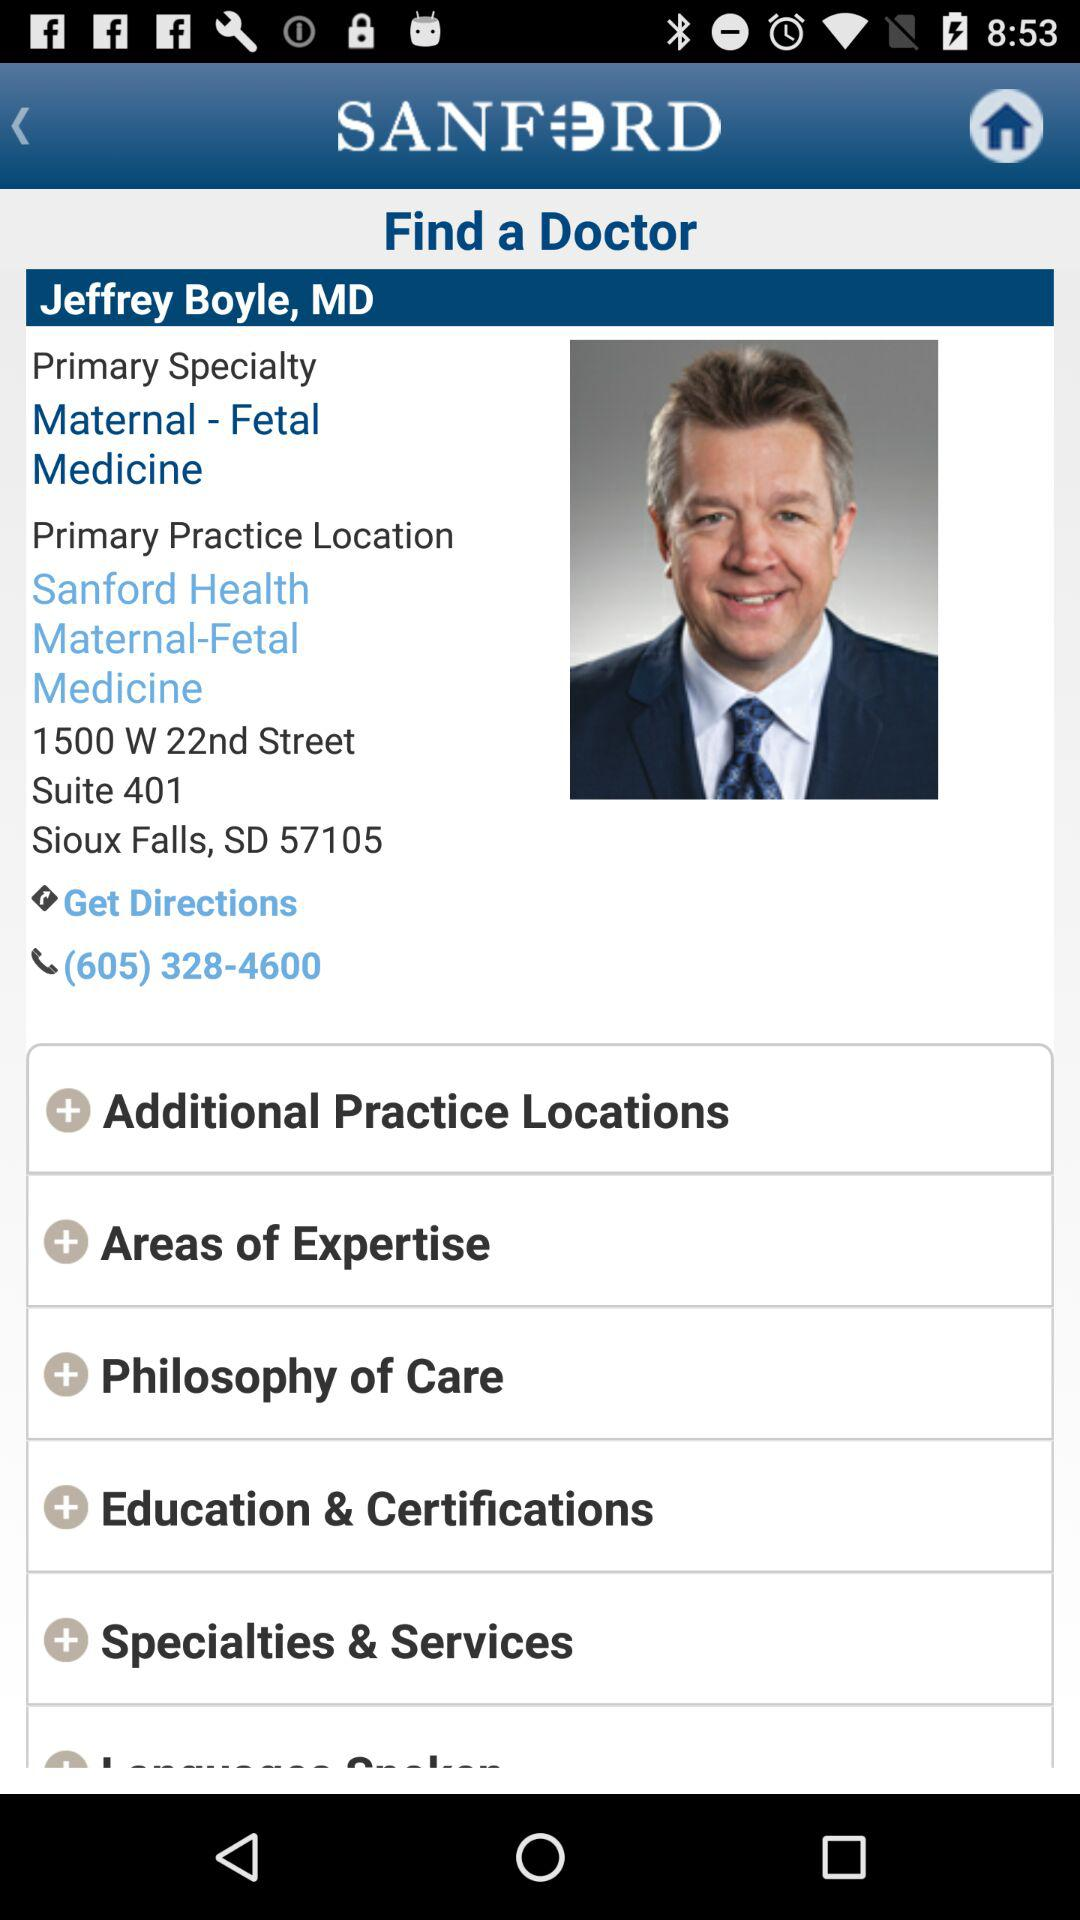What is the pin code? The pin code is 57105. 